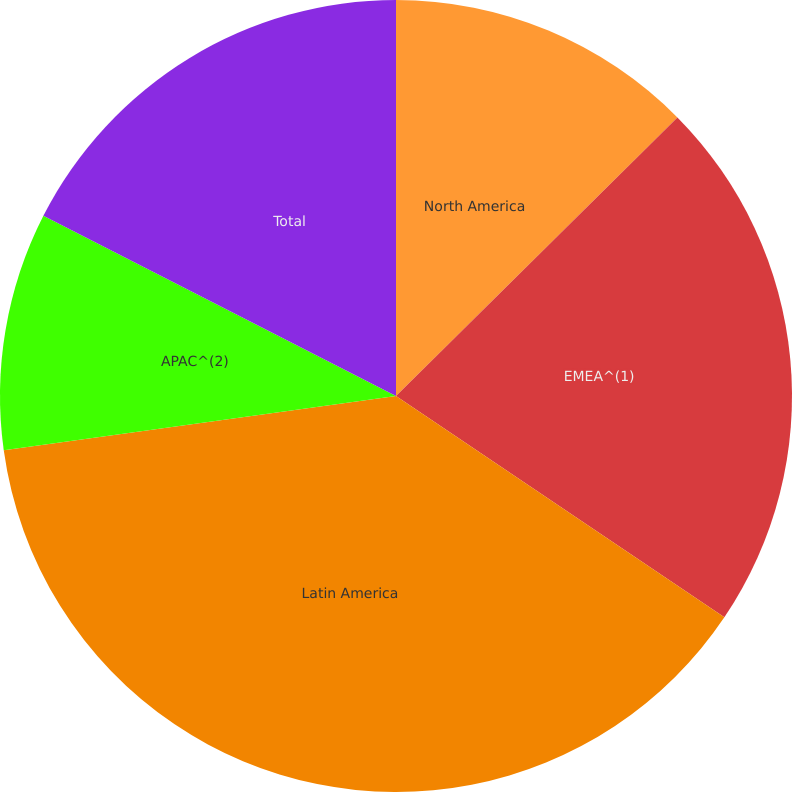Convert chart. <chart><loc_0><loc_0><loc_500><loc_500><pie_chart><fcel>North America<fcel>EMEA^(1)<fcel>Latin America<fcel>APAC^(2)<fcel>Total<nl><fcel>12.58%<fcel>21.86%<fcel>38.37%<fcel>9.71%<fcel>17.48%<nl></chart> 